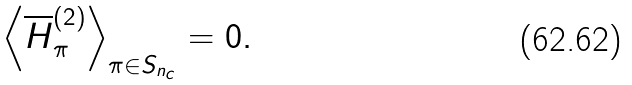<formula> <loc_0><loc_0><loc_500><loc_500>\left \langle \overline { H } ^ { ( 2 ) } _ { \pi } \right \rangle _ { \pi \in S _ { n _ { c } } } = 0 .</formula> 